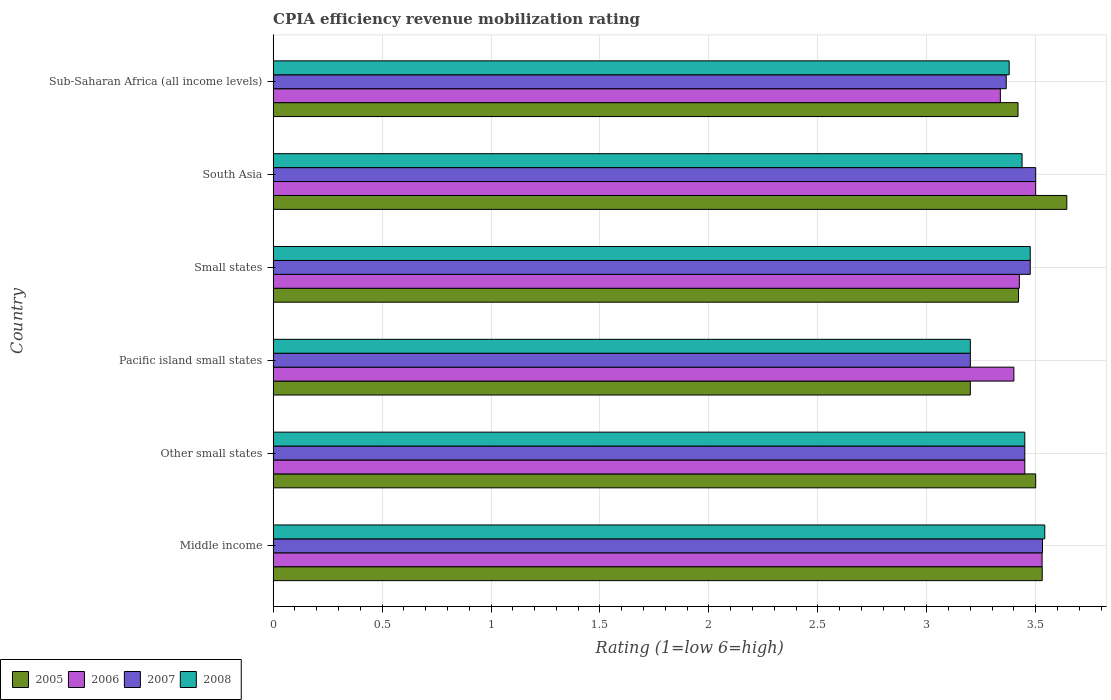How many groups of bars are there?
Your answer should be compact. 6. Are the number of bars per tick equal to the number of legend labels?
Offer a terse response. Yes. Are the number of bars on each tick of the Y-axis equal?
Make the answer very short. Yes. How many bars are there on the 1st tick from the bottom?
Your answer should be very brief. 4. What is the label of the 4th group of bars from the top?
Provide a short and direct response. Pacific island small states. In how many cases, is the number of bars for a given country not equal to the number of legend labels?
Give a very brief answer. 0. What is the CPIA rating in 2007 in South Asia?
Ensure brevity in your answer.  3.5. Across all countries, what is the maximum CPIA rating in 2005?
Keep it short and to the point. 3.64. Across all countries, what is the minimum CPIA rating in 2006?
Ensure brevity in your answer.  3.34. In which country was the CPIA rating in 2005 minimum?
Your response must be concise. Pacific island small states. What is the total CPIA rating in 2006 in the graph?
Your answer should be very brief. 20.64. What is the difference between the CPIA rating in 2007 in Pacific island small states and that in South Asia?
Give a very brief answer. -0.3. What is the difference between the CPIA rating in 2005 in Sub-Saharan Africa (all income levels) and the CPIA rating in 2006 in Middle income?
Offer a very short reply. -0.11. What is the average CPIA rating in 2008 per country?
Ensure brevity in your answer.  3.41. What is the difference between the CPIA rating in 2005 and CPIA rating in 2006 in Sub-Saharan Africa (all income levels)?
Keep it short and to the point. 0.08. In how many countries, is the CPIA rating in 2005 greater than 3.2 ?
Provide a short and direct response. 5. What is the ratio of the CPIA rating in 2006 in Other small states to that in Pacific island small states?
Make the answer very short. 1.01. Is the CPIA rating in 2005 in Other small states less than that in South Asia?
Provide a short and direct response. Yes. Is the difference between the CPIA rating in 2005 in Other small states and Sub-Saharan Africa (all income levels) greater than the difference between the CPIA rating in 2006 in Other small states and Sub-Saharan Africa (all income levels)?
Your answer should be compact. No. What is the difference between the highest and the second highest CPIA rating in 2008?
Ensure brevity in your answer.  0.07. What is the difference between the highest and the lowest CPIA rating in 2005?
Make the answer very short. 0.44. In how many countries, is the CPIA rating in 2005 greater than the average CPIA rating in 2005 taken over all countries?
Provide a succinct answer. 3. Is the sum of the CPIA rating in 2005 in Small states and Sub-Saharan Africa (all income levels) greater than the maximum CPIA rating in 2008 across all countries?
Keep it short and to the point. Yes. What does the 2nd bar from the top in Sub-Saharan Africa (all income levels) represents?
Offer a terse response. 2007. Is it the case that in every country, the sum of the CPIA rating in 2006 and CPIA rating in 2008 is greater than the CPIA rating in 2005?
Ensure brevity in your answer.  Yes. What is the difference between two consecutive major ticks on the X-axis?
Provide a succinct answer. 0.5. Does the graph contain any zero values?
Offer a very short reply. No. How many legend labels are there?
Ensure brevity in your answer.  4. What is the title of the graph?
Offer a terse response. CPIA efficiency revenue mobilization rating. What is the Rating (1=low 6=high) in 2005 in Middle income?
Provide a short and direct response. 3.53. What is the Rating (1=low 6=high) in 2006 in Middle income?
Provide a succinct answer. 3.53. What is the Rating (1=low 6=high) in 2007 in Middle income?
Offer a terse response. 3.53. What is the Rating (1=low 6=high) of 2008 in Middle income?
Your answer should be very brief. 3.54. What is the Rating (1=low 6=high) of 2006 in Other small states?
Your answer should be compact. 3.45. What is the Rating (1=low 6=high) in 2007 in Other small states?
Offer a very short reply. 3.45. What is the Rating (1=low 6=high) in 2008 in Other small states?
Your answer should be very brief. 3.45. What is the Rating (1=low 6=high) of 2005 in Small states?
Your response must be concise. 3.42. What is the Rating (1=low 6=high) in 2006 in Small states?
Make the answer very short. 3.42. What is the Rating (1=low 6=high) of 2007 in Small states?
Provide a succinct answer. 3.48. What is the Rating (1=low 6=high) of 2008 in Small states?
Give a very brief answer. 3.48. What is the Rating (1=low 6=high) of 2005 in South Asia?
Your answer should be compact. 3.64. What is the Rating (1=low 6=high) of 2006 in South Asia?
Provide a short and direct response. 3.5. What is the Rating (1=low 6=high) of 2008 in South Asia?
Your answer should be compact. 3.44. What is the Rating (1=low 6=high) in 2005 in Sub-Saharan Africa (all income levels)?
Keep it short and to the point. 3.42. What is the Rating (1=low 6=high) of 2006 in Sub-Saharan Africa (all income levels)?
Provide a succinct answer. 3.34. What is the Rating (1=low 6=high) in 2007 in Sub-Saharan Africa (all income levels)?
Make the answer very short. 3.36. What is the Rating (1=low 6=high) in 2008 in Sub-Saharan Africa (all income levels)?
Make the answer very short. 3.38. Across all countries, what is the maximum Rating (1=low 6=high) of 2005?
Ensure brevity in your answer.  3.64. Across all countries, what is the maximum Rating (1=low 6=high) of 2006?
Offer a terse response. 3.53. Across all countries, what is the maximum Rating (1=low 6=high) in 2007?
Make the answer very short. 3.53. Across all countries, what is the maximum Rating (1=low 6=high) in 2008?
Give a very brief answer. 3.54. Across all countries, what is the minimum Rating (1=low 6=high) in 2006?
Your response must be concise. 3.34. Across all countries, what is the minimum Rating (1=low 6=high) in 2007?
Offer a very short reply. 3.2. Across all countries, what is the minimum Rating (1=low 6=high) of 2008?
Offer a very short reply. 3.2. What is the total Rating (1=low 6=high) of 2005 in the graph?
Provide a succinct answer. 20.71. What is the total Rating (1=low 6=high) in 2006 in the graph?
Give a very brief answer. 20.64. What is the total Rating (1=low 6=high) of 2007 in the graph?
Offer a terse response. 20.52. What is the total Rating (1=low 6=high) of 2008 in the graph?
Your answer should be compact. 20.48. What is the difference between the Rating (1=low 6=high) of 2005 in Middle income and that in Other small states?
Make the answer very short. 0.03. What is the difference between the Rating (1=low 6=high) in 2006 in Middle income and that in Other small states?
Give a very brief answer. 0.08. What is the difference between the Rating (1=low 6=high) in 2007 in Middle income and that in Other small states?
Your answer should be very brief. 0.08. What is the difference between the Rating (1=low 6=high) in 2008 in Middle income and that in Other small states?
Your response must be concise. 0.09. What is the difference between the Rating (1=low 6=high) in 2005 in Middle income and that in Pacific island small states?
Offer a terse response. 0.33. What is the difference between the Rating (1=low 6=high) of 2006 in Middle income and that in Pacific island small states?
Ensure brevity in your answer.  0.13. What is the difference between the Rating (1=low 6=high) of 2007 in Middle income and that in Pacific island small states?
Your answer should be compact. 0.33. What is the difference between the Rating (1=low 6=high) of 2008 in Middle income and that in Pacific island small states?
Your answer should be compact. 0.34. What is the difference between the Rating (1=low 6=high) of 2005 in Middle income and that in Small states?
Provide a short and direct response. 0.11. What is the difference between the Rating (1=low 6=high) in 2006 in Middle income and that in Small states?
Your answer should be compact. 0.1. What is the difference between the Rating (1=low 6=high) in 2007 in Middle income and that in Small states?
Give a very brief answer. 0.06. What is the difference between the Rating (1=low 6=high) in 2008 in Middle income and that in Small states?
Offer a terse response. 0.07. What is the difference between the Rating (1=low 6=high) of 2005 in Middle income and that in South Asia?
Offer a very short reply. -0.11. What is the difference between the Rating (1=low 6=high) in 2006 in Middle income and that in South Asia?
Ensure brevity in your answer.  0.03. What is the difference between the Rating (1=low 6=high) in 2007 in Middle income and that in South Asia?
Your response must be concise. 0.03. What is the difference between the Rating (1=low 6=high) in 2008 in Middle income and that in South Asia?
Your answer should be compact. 0.1. What is the difference between the Rating (1=low 6=high) in 2006 in Middle income and that in Sub-Saharan Africa (all income levels)?
Offer a terse response. 0.19. What is the difference between the Rating (1=low 6=high) in 2007 in Middle income and that in Sub-Saharan Africa (all income levels)?
Offer a very short reply. 0.17. What is the difference between the Rating (1=low 6=high) in 2008 in Middle income and that in Sub-Saharan Africa (all income levels)?
Give a very brief answer. 0.16. What is the difference between the Rating (1=low 6=high) in 2005 in Other small states and that in Pacific island small states?
Offer a terse response. 0.3. What is the difference between the Rating (1=low 6=high) of 2005 in Other small states and that in Small states?
Your answer should be compact. 0.08. What is the difference between the Rating (1=low 6=high) in 2006 in Other small states and that in Small states?
Ensure brevity in your answer.  0.03. What is the difference between the Rating (1=low 6=high) in 2007 in Other small states and that in Small states?
Give a very brief answer. -0.03. What is the difference between the Rating (1=low 6=high) in 2008 in Other small states and that in Small states?
Your answer should be compact. -0.03. What is the difference between the Rating (1=low 6=high) in 2005 in Other small states and that in South Asia?
Your answer should be very brief. -0.14. What is the difference between the Rating (1=low 6=high) in 2008 in Other small states and that in South Asia?
Offer a very short reply. 0.01. What is the difference between the Rating (1=low 6=high) of 2005 in Other small states and that in Sub-Saharan Africa (all income levels)?
Ensure brevity in your answer.  0.08. What is the difference between the Rating (1=low 6=high) in 2006 in Other small states and that in Sub-Saharan Africa (all income levels)?
Provide a short and direct response. 0.11. What is the difference between the Rating (1=low 6=high) in 2007 in Other small states and that in Sub-Saharan Africa (all income levels)?
Keep it short and to the point. 0.09. What is the difference between the Rating (1=low 6=high) in 2008 in Other small states and that in Sub-Saharan Africa (all income levels)?
Offer a terse response. 0.07. What is the difference between the Rating (1=low 6=high) in 2005 in Pacific island small states and that in Small states?
Make the answer very short. -0.22. What is the difference between the Rating (1=low 6=high) of 2006 in Pacific island small states and that in Small states?
Your answer should be very brief. -0.03. What is the difference between the Rating (1=low 6=high) of 2007 in Pacific island small states and that in Small states?
Your answer should be very brief. -0.28. What is the difference between the Rating (1=low 6=high) in 2008 in Pacific island small states and that in Small states?
Your response must be concise. -0.28. What is the difference between the Rating (1=low 6=high) in 2005 in Pacific island small states and that in South Asia?
Give a very brief answer. -0.44. What is the difference between the Rating (1=low 6=high) in 2007 in Pacific island small states and that in South Asia?
Your answer should be very brief. -0.3. What is the difference between the Rating (1=low 6=high) of 2008 in Pacific island small states and that in South Asia?
Ensure brevity in your answer.  -0.24. What is the difference between the Rating (1=low 6=high) of 2005 in Pacific island small states and that in Sub-Saharan Africa (all income levels)?
Offer a very short reply. -0.22. What is the difference between the Rating (1=low 6=high) of 2006 in Pacific island small states and that in Sub-Saharan Africa (all income levels)?
Offer a terse response. 0.06. What is the difference between the Rating (1=low 6=high) in 2007 in Pacific island small states and that in Sub-Saharan Africa (all income levels)?
Offer a very short reply. -0.16. What is the difference between the Rating (1=low 6=high) in 2008 in Pacific island small states and that in Sub-Saharan Africa (all income levels)?
Keep it short and to the point. -0.18. What is the difference between the Rating (1=low 6=high) of 2005 in Small states and that in South Asia?
Provide a short and direct response. -0.22. What is the difference between the Rating (1=low 6=high) of 2006 in Small states and that in South Asia?
Your answer should be very brief. -0.07. What is the difference between the Rating (1=low 6=high) of 2007 in Small states and that in South Asia?
Keep it short and to the point. -0.03. What is the difference between the Rating (1=low 6=high) of 2008 in Small states and that in South Asia?
Your answer should be compact. 0.04. What is the difference between the Rating (1=low 6=high) of 2005 in Small states and that in Sub-Saharan Africa (all income levels)?
Keep it short and to the point. 0. What is the difference between the Rating (1=low 6=high) of 2006 in Small states and that in Sub-Saharan Africa (all income levels)?
Your answer should be very brief. 0.09. What is the difference between the Rating (1=low 6=high) in 2007 in Small states and that in Sub-Saharan Africa (all income levels)?
Your answer should be very brief. 0.11. What is the difference between the Rating (1=low 6=high) in 2008 in Small states and that in Sub-Saharan Africa (all income levels)?
Offer a terse response. 0.1. What is the difference between the Rating (1=low 6=high) in 2005 in South Asia and that in Sub-Saharan Africa (all income levels)?
Your answer should be very brief. 0.22. What is the difference between the Rating (1=low 6=high) in 2006 in South Asia and that in Sub-Saharan Africa (all income levels)?
Offer a terse response. 0.16. What is the difference between the Rating (1=low 6=high) of 2007 in South Asia and that in Sub-Saharan Africa (all income levels)?
Make the answer very short. 0.14. What is the difference between the Rating (1=low 6=high) of 2008 in South Asia and that in Sub-Saharan Africa (all income levels)?
Offer a very short reply. 0.06. What is the difference between the Rating (1=low 6=high) in 2005 in Middle income and the Rating (1=low 6=high) in 2008 in Other small states?
Provide a succinct answer. 0.08. What is the difference between the Rating (1=low 6=high) of 2006 in Middle income and the Rating (1=low 6=high) of 2007 in Other small states?
Provide a succinct answer. 0.08. What is the difference between the Rating (1=low 6=high) in 2006 in Middle income and the Rating (1=low 6=high) in 2008 in Other small states?
Your response must be concise. 0.08. What is the difference between the Rating (1=low 6=high) in 2007 in Middle income and the Rating (1=low 6=high) in 2008 in Other small states?
Keep it short and to the point. 0.08. What is the difference between the Rating (1=low 6=high) in 2005 in Middle income and the Rating (1=low 6=high) in 2006 in Pacific island small states?
Offer a terse response. 0.13. What is the difference between the Rating (1=low 6=high) in 2005 in Middle income and the Rating (1=low 6=high) in 2007 in Pacific island small states?
Keep it short and to the point. 0.33. What is the difference between the Rating (1=low 6=high) of 2005 in Middle income and the Rating (1=low 6=high) of 2008 in Pacific island small states?
Your response must be concise. 0.33. What is the difference between the Rating (1=low 6=high) of 2006 in Middle income and the Rating (1=low 6=high) of 2007 in Pacific island small states?
Offer a very short reply. 0.33. What is the difference between the Rating (1=low 6=high) in 2006 in Middle income and the Rating (1=low 6=high) in 2008 in Pacific island small states?
Offer a very short reply. 0.33. What is the difference between the Rating (1=low 6=high) in 2007 in Middle income and the Rating (1=low 6=high) in 2008 in Pacific island small states?
Your response must be concise. 0.33. What is the difference between the Rating (1=low 6=high) in 2005 in Middle income and the Rating (1=low 6=high) in 2006 in Small states?
Your answer should be compact. 0.1. What is the difference between the Rating (1=low 6=high) of 2005 in Middle income and the Rating (1=low 6=high) of 2007 in Small states?
Make the answer very short. 0.06. What is the difference between the Rating (1=low 6=high) in 2005 in Middle income and the Rating (1=low 6=high) in 2008 in Small states?
Offer a very short reply. 0.06. What is the difference between the Rating (1=low 6=high) of 2006 in Middle income and the Rating (1=low 6=high) of 2007 in Small states?
Your answer should be very brief. 0.05. What is the difference between the Rating (1=low 6=high) of 2006 in Middle income and the Rating (1=low 6=high) of 2008 in Small states?
Offer a very short reply. 0.05. What is the difference between the Rating (1=low 6=high) in 2007 in Middle income and the Rating (1=low 6=high) in 2008 in Small states?
Your response must be concise. 0.06. What is the difference between the Rating (1=low 6=high) of 2005 in Middle income and the Rating (1=low 6=high) of 2008 in South Asia?
Make the answer very short. 0.09. What is the difference between the Rating (1=low 6=high) of 2006 in Middle income and the Rating (1=low 6=high) of 2007 in South Asia?
Offer a terse response. 0.03. What is the difference between the Rating (1=low 6=high) of 2006 in Middle income and the Rating (1=low 6=high) of 2008 in South Asia?
Ensure brevity in your answer.  0.09. What is the difference between the Rating (1=low 6=high) in 2007 in Middle income and the Rating (1=low 6=high) in 2008 in South Asia?
Provide a short and direct response. 0.09. What is the difference between the Rating (1=low 6=high) in 2005 in Middle income and the Rating (1=low 6=high) in 2006 in Sub-Saharan Africa (all income levels)?
Provide a succinct answer. 0.19. What is the difference between the Rating (1=low 6=high) of 2005 in Middle income and the Rating (1=low 6=high) of 2007 in Sub-Saharan Africa (all income levels)?
Your answer should be very brief. 0.17. What is the difference between the Rating (1=low 6=high) of 2005 in Middle income and the Rating (1=low 6=high) of 2008 in Sub-Saharan Africa (all income levels)?
Provide a succinct answer. 0.15. What is the difference between the Rating (1=low 6=high) of 2006 in Middle income and the Rating (1=low 6=high) of 2007 in Sub-Saharan Africa (all income levels)?
Keep it short and to the point. 0.16. What is the difference between the Rating (1=low 6=high) of 2006 in Middle income and the Rating (1=low 6=high) of 2008 in Sub-Saharan Africa (all income levels)?
Offer a terse response. 0.15. What is the difference between the Rating (1=low 6=high) of 2007 in Middle income and the Rating (1=low 6=high) of 2008 in Sub-Saharan Africa (all income levels)?
Provide a short and direct response. 0.15. What is the difference between the Rating (1=low 6=high) of 2005 in Other small states and the Rating (1=low 6=high) of 2007 in Pacific island small states?
Make the answer very short. 0.3. What is the difference between the Rating (1=low 6=high) of 2007 in Other small states and the Rating (1=low 6=high) of 2008 in Pacific island small states?
Keep it short and to the point. 0.25. What is the difference between the Rating (1=low 6=high) in 2005 in Other small states and the Rating (1=low 6=high) in 2006 in Small states?
Ensure brevity in your answer.  0.07. What is the difference between the Rating (1=low 6=high) in 2005 in Other small states and the Rating (1=low 6=high) in 2007 in Small states?
Your answer should be very brief. 0.03. What is the difference between the Rating (1=low 6=high) of 2005 in Other small states and the Rating (1=low 6=high) of 2008 in Small states?
Provide a succinct answer. 0.03. What is the difference between the Rating (1=low 6=high) of 2006 in Other small states and the Rating (1=low 6=high) of 2007 in Small states?
Offer a terse response. -0.03. What is the difference between the Rating (1=low 6=high) of 2006 in Other small states and the Rating (1=low 6=high) of 2008 in Small states?
Keep it short and to the point. -0.03. What is the difference between the Rating (1=low 6=high) in 2007 in Other small states and the Rating (1=low 6=high) in 2008 in Small states?
Offer a terse response. -0.03. What is the difference between the Rating (1=low 6=high) in 2005 in Other small states and the Rating (1=low 6=high) in 2006 in South Asia?
Offer a terse response. 0. What is the difference between the Rating (1=low 6=high) in 2005 in Other small states and the Rating (1=low 6=high) in 2007 in South Asia?
Ensure brevity in your answer.  0. What is the difference between the Rating (1=low 6=high) of 2005 in Other small states and the Rating (1=low 6=high) of 2008 in South Asia?
Your answer should be very brief. 0.06. What is the difference between the Rating (1=low 6=high) of 2006 in Other small states and the Rating (1=low 6=high) of 2007 in South Asia?
Ensure brevity in your answer.  -0.05. What is the difference between the Rating (1=low 6=high) in 2006 in Other small states and the Rating (1=low 6=high) in 2008 in South Asia?
Provide a succinct answer. 0.01. What is the difference between the Rating (1=low 6=high) of 2007 in Other small states and the Rating (1=low 6=high) of 2008 in South Asia?
Make the answer very short. 0.01. What is the difference between the Rating (1=low 6=high) of 2005 in Other small states and the Rating (1=low 6=high) of 2006 in Sub-Saharan Africa (all income levels)?
Keep it short and to the point. 0.16. What is the difference between the Rating (1=low 6=high) in 2005 in Other small states and the Rating (1=low 6=high) in 2007 in Sub-Saharan Africa (all income levels)?
Your response must be concise. 0.14. What is the difference between the Rating (1=low 6=high) in 2005 in Other small states and the Rating (1=low 6=high) in 2008 in Sub-Saharan Africa (all income levels)?
Keep it short and to the point. 0.12. What is the difference between the Rating (1=low 6=high) in 2006 in Other small states and the Rating (1=low 6=high) in 2007 in Sub-Saharan Africa (all income levels)?
Make the answer very short. 0.09. What is the difference between the Rating (1=low 6=high) in 2006 in Other small states and the Rating (1=low 6=high) in 2008 in Sub-Saharan Africa (all income levels)?
Make the answer very short. 0.07. What is the difference between the Rating (1=low 6=high) in 2007 in Other small states and the Rating (1=low 6=high) in 2008 in Sub-Saharan Africa (all income levels)?
Offer a terse response. 0.07. What is the difference between the Rating (1=low 6=high) in 2005 in Pacific island small states and the Rating (1=low 6=high) in 2006 in Small states?
Your answer should be very brief. -0.23. What is the difference between the Rating (1=low 6=high) of 2005 in Pacific island small states and the Rating (1=low 6=high) of 2007 in Small states?
Your response must be concise. -0.28. What is the difference between the Rating (1=low 6=high) in 2005 in Pacific island small states and the Rating (1=low 6=high) in 2008 in Small states?
Give a very brief answer. -0.28. What is the difference between the Rating (1=low 6=high) in 2006 in Pacific island small states and the Rating (1=low 6=high) in 2007 in Small states?
Make the answer very short. -0.07. What is the difference between the Rating (1=low 6=high) in 2006 in Pacific island small states and the Rating (1=low 6=high) in 2008 in Small states?
Your answer should be compact. -0.07. What is the difference between the Rating (1=low 6=high) in 2007 in Pacific island small states and the Rating (1=low 6=high) in 2008 in Small states?
Your response must be concise. -0.28. What is the difference between the Rating (1=low 6=high) of 2005 in Pacific island small states and the Rating (1=low 6=high) of 2007 in South Asia?
Your answer should be compact. -0.3. What is the difference between the Rating (1=low 6=high) of 2005 in Pacific island small states and the Rating (1=low 6=high) of 2008 in South Asia?
Provide a short and direct response. -0.24. What is the difference between the Rating (1=low 6=high) of 2006 in Pacific island small states and the Rating (1=low 6=high) of 2008 in South Asia?
Your response must be concise. -0.04. What is the difference between the Rating (1=low 6=high) of 2007 in Pacific island small states and the Rating (1=low 6=high) of 2008 in South Asia?
Ensure brevity in your answer.  -0.24. What is the difference between the Rating (1=low 6=high) of 2005 in Pacific island small states and the Rating (1=low 6=high) of 2006 in Sub-Saharan Africa (all income levels)?
Ensure brevity in your answer.  -0.14. What is the difference between the Rating (1=low 6=high) in 2005 in Pacific island small states and the Rating (1=low 6=high) in 2007 in Sub-Saharan Africa (all income levels)?
Keep it short and to the point. -0.16. What is the difference between the Rating (1=low 6=high) in 2005 in Pacific island small states and the Rating (1=low 6=high) in 2008 in Sub-Saharan Africa (all income levels)?
Offer a very short reply. -0.18. What is the difference between the Rating (1=low 6=high) in 2006 in Pacific island small states and the Rating (1=low 6=high) in 2007 in Sub-Saharan Africa (all income levels)?
Your answer should be very brief. 0.04. What is the difference between the Rating (1=low 6=high) in 2006 in Pacific island small states and the Rating (1=low 6=high) in 2008 in Sub-Saharan Africa (all income levels)?
Offer a terse response. 0.02. What is the difference between the Rating (1=low 6=high) of 2007 in Pacific island small states and the Rating (1=low 6=high) of 2008 in Sub-Saharan Africa (all income levels)?
Give a very brief answer. -0.18. What is the difference between the Rating (1=low 6=high) in 2005 in Small states and the Rating (1=low 6=high) in 2006 in South Asia?
Keep it short and to the point. -0.08. What is the difference between the Rating (1=low 6=high) in 2005 in Small states and the Rating (1=low 6=high) in 2007 in South Asia?
Your response must be concise. -0.08. What is the difference between the Rating (1=low 6=high) in 2005 in Small states and the Rating (1=low 6=high) in 2008 in South Asia?
Ensure brevity in your answer.  -0.02. What is the difference between the Rating (1=low 6=high) in 2006 in Small states and the Rating (1=low 6=high) in 2007 in South Asia?
Your response must be concise. -0.07. What is the difference between the Rating (1=low 6=high) in 2006 in Small states and the Rating (1=low 6=high) in 2008 in South Asia?
Your response must be concise. -0.01. What is the difference between the Rating (1=low 6=high) in 2007 in Small states and the Rating (1=low 6=high) in 2008 in South Asia?
Offer a very short reply. 0.04. What is the difference between the Rating (1=low 6=high) in 2005 in Small states and the Rating (1=low 6=high) in 2006 in Sub-Saharan Africa (all income levels)?
Make the answer very short. 0.08. What is the difference between the Rating (1=low 6=high) of 2005 in Small states and the Rating (1=low 6=high) of 2007 in Sub-Saharan Africa (all income levels)?
Keep it short and to the point. 0.06. What is the difference between the Rating (1=low 6=high) of 2005 in Small states and the Rating (1=low 6=high) of 2008 in Sub-Saharan Africa (all income levels)?
Keep it short and to the point. 0.04. What is the difference between the Rating (1=low 6=high) in 2006 in Small states and the Rating (1=low 6=high) in 2007 in Sub-Saharan Africa (all income levels)?
Offer a terse response. 0.06. What is the difference between the Rating (1=low 6=high) of 2006 in Small states and the Rating (1=low 6=high) of 2008 in Sub-Saharan Africa (all income levels)?
Make the answer very short. 0.05. What is the difference between the Rating (1=low 6=high) of 2007 in Small states and the Rating (1=low 6=high) of 2008 in Sub-Saharan Africa (all income levels)?
Ensure brevity in your answer.  0.1. What is the difference between the Rating (1=low 6=high) of 2005 in South Asia and the Rating (1=low 6=high) of 2006 in Sub-Saharan Africa (all income levels)?
Offer a very short reply. 0.3. What is the difference between the Rating (1=low 6=high) in 2005 in South Asia and the Rating (1=low 6=high) in 2007 in Sub-Saharan Africa (all income levels)?
Keep it short and to the point. 0.28. What is the difference between the Rating (1=low 6=high) of 2005 in South Asia and the Rating (1=low 6=high) of 2008 in Sub-Saharan Africa (all income levels)?
Give a very brief answer. 0.26. What is the difference between the Rating (1=low 6=high) of 2006 in South Asia and the Rating (1=low 6=high) of 2007 in Sub-Saharan Africa (all income levels)?
Provide a short and direct response. 0.14. What is the difference between the Rating (1=low 6=high) in 2006 in South Asia and the Rating (1=low 6=high) in 2008 in Sub-Saharan Africa (all income levels)?
Offer a very short reply. 0.12. What is the difference between the Rating (1=low 6=high) in 2007 in South Asia and the Rating (1=low 6=high) in 2008 in Sub-Saharan Africa (all income levels)?
Your response must be concise. 0.12. What is the average Rating (1=low 6=high) of 2005 per country?
Give a very brief answer. 3.45. What is the average Rating (1=low 6=high) in 2006 per country?
Ensure brevity in your answer.  3.44. What is the average Rating (1=low 6=high) in 2007 per country?
Make the answer very short. 3.42. What is the average Rating (1=low 6=high) in 2008 per country?
Keep it short and to the point. 3.41. What is the difference between the Rating (1=low 6=high) of 2005 and Rating (1=low 6=high) of 2006 in Middle income?
Your answer should be compact. 0. What is the difference between the Rating (1=low 6=high) in 2005 and Rating (1=low 6=high) in 2007 in Middle income?
Your response must be concise. -0. What is the difference between the Rating (1=low 6=high) of 2005 and Rating (1=low 6=high) of 2008 in Middle income?
Ensure brevity in your answer.  -0.01. What is the difference between the Rating (1=low 6=high) in 2006 and Rating (1=low 6=high) in 2007 in Middle income?
Offer a very short reply. -0. What is the difference between the Rating (1=low 6=high) of 2006 and Rating (1=low 6=high) of 2008 in Middle income?
Ensure brevity in your answer.  -0.01. What is the difference between the Rating (1=low 6=high) of 2007 and Rating (1=low 6=high) of 2008 in Middle income?
Offer a very short reply. -0.01. What is the difference between the Rating (1=low 6=high) of 2005 and Rating (1=low 6=high) of 2007 in Other small states?
Provide a short and direct response. 0.05. What is the difference between the Rating (1=low 6=high) of 2005 and Rating (1=low 6=high) of 2008 in Other small states?
Keep it short and to the point. 0.05. What is the difference between the Rating (1=low 6=high) in 2006 and Rating (1=low 6=high) in 2008 in Other small states?
Give a very brief answer. 0. What is the difference between the Rating (1=low 6=high) of 2007 and Rating (1=low 6=high) of 2008 in Other small states?
Ensure brevity in your answer.  0. What is the difference between the Rating (1=low 6=high) of 2005 and Rating (1=low 6=high) of 2006 in Pacific island small states?
Offer a very short reply. -0.2. What is the difference between the Rating (1=low 6=high) of 2005 and Rating (1=low 6=high) of 2007 in Pacific island small states?
Offer a very short reply. 0. What is the difference between the Rating (1=low 6=high) of 2006 and Rating (1=low 6=high) of 2007 in Pacific island small states?
Provide a succinct answer. 0.2. What is the difference between the Rating (1=low 6=high) of 2006 and Rating (1=low 6=high) of 2008 in Pacific island small states?
Your response must be concise. 0.2. What is the difference between the Rating (1=low 6=high) of 2005 and Rating (1=low 6=high) of 2006 in Small states?
Your answer should be compact. -0. What is the difference between the Rating (1=low 6=high) of 2005 and Rating (1=low 6=high) of 2007 in Small states?
Your answer should be very brief. -0.05. What is the difference between the Rating (1=low 6=high) of 2005 and Rating (1=low 6=high) of 2008 in Small states?
Your answer should be compact. -0.05. What is the difference between the Rating (1=low 6=high) of 2006 and Rating (1=low 6=high) of 2008 in Small states?
Offer a very short reply. -0.05. What is the difference between the Rating (1=low 6=high) of 2007 and Rating (1=low 6=high) of 2008 in Small states?
Provide a short and direct response. 0. What is the difference between the Rating (1=low 6=high) of 2005 and Rating (1=low 6=high) of 2006 in South Asia?
Give a very brief answer. 0.14. What is the difference between the Rating (1=low 6=high) in 2005 and Rating (1=low 6=high) in 2007 in South Asia?
Ensure brevity in your answer.  0.14. What is the difference between the Rating (1=low 6=high) in 2005 and Rating (1=low 6=high) in 2008 in South Asia?
Make the answer very short. 0.21. What is the difference between the Rating (1=low 6=high) of 2006 and Rating (1=low 6=high) of 2007 in South Asia?
Keep it short and to the point. 0. What is the difference between the Rating (1=low 6=high) of 2006 and Rating (1=low 6=high) of 2008 in South Asia?
Your response must be concise. 0.06. What is the difference between the Rating (1=low 6=high) of 2007 and Rating (1=low 6=high) of 2008 in South Asia?
Offer a terse response. 0.06. What is the difference between the Rating (1=low 6=high) of 2005 and Rating (1=low 6=high) of 2006 in Sub-Saharan Africa (all income levels)?
Give a very brief answer. 0.08. What is the difference between the Rating (1=low 6=high) of 2005 and Rating (1=low 6=high) of 2007 in Sub-Saharan Africa (all income levels)?
Offer a very short reply. 0.05. What is the difference between the Rating (1=low 6=high) of 2005 and Rating (1=low 6=high) of 2008 in Sub-Saharan Africa (all income levels)?
Make the answer very short. 0.04. What is the difference between the Rating (1=low 6=high) in 2006 and Rating (1=low 6=high) in 2007 in Sub-Saharan Africa (all income levels)?
Your answer should be compact. -0.03. What is the difference between the Rating (1=low 6=high) in 2006 and Rating (1=low 6=high) in 2008 in Sub-Saharan Africa (all income levels)?
Provide a short and direct response. -0.04. What is the difference between the Rating (1=low 6=high) in 2007 and Rating (1=low 6=high) in 2008 in Sub-Saharan Africa (all income levels)?
Keep it short and to the point. -0.01. What is the ratio of the Rating (1=low 6=high) of 2005 in Middle income to that in Other small states?
Make the answer very short. 1.01. What is the ratio of the Rating (1=low 6=high) of 2007 in Middle income to that in Other small states?
Ensure brevity in your answer.  1.02. What is the ratio of the Rating (1=low 6=high) of 2008 in Middle income to that in Other small states?
Ensure brevity in your answer.  1.03. What is the ratio of the Rating (1=low 6=high) of 2005 in Middle income to that in Pacific island small states?
Offer a terse response. 1.1. What is the ratio of the Rating (1=low 6=high) in 2006 in Middle income to that in Pacific island small states?
Your answer should be very brief. 1.04. What is the ratio of the Rating (1=low 6=high) in 2007 in Middle income to that in Pacific island small states?
Provide a short and direct response. 1.1. What is the ratio of the Rating (1=low 6=high) in 2008 in Middle income to that in Pacific island small states?
Keep it short and to the point. 1.11. What is the ratio of the Rating (1=low 6=high) of 2005 in Middle income to that in Small states?
Your answer should be compact. 1.03. What is the ratio of the Rating (1=low 6=high) of 2006 in Middle income to that in Small states?
Make the answer very short. 1.03. What is the ratio of the Rating (1=low 6=high) of 2007 in Middle income to that in Small states?
Offer a terse response. 1.02. What is the ratio of the Rating (1=low 6=high) of 2008 in Middle income to that in Small states?
Your answer should be compact. 1.02. What is the ratio of the Rating (1=low 6=high) in 2006 in Middle income to that in South Asia?
Your response must be concise. 1.01. What is the ratio of the Rating (1=low 6=high) of 2007 in Middle income to that in South Asia?
Keep it short and to the point. 1.01. What is the ratio of the Rating (1=low 6=high) of 2008 in Middle income to that in South Asia?
Give a very brief answer. 1.03. What is the ratio of the Rating (1=low 6=high) in 2005 in Middle income to that in Sub-Saharan Africa (all income levels)?
Offer a terse response. 1.03. What is the ratio of the Rating (1=low 6=high) in 2006 in Middle income to that in Sub-Saharan Africa (all income levels)?
Provide a short and direct response. 1.06. What is the ratio of the Rating (1=low 6=high) of 2007 in Middle income to that in Sub-Saharan Africa (all income levels)?
Keep it short and to the point. 1.05. What is the ratio of the Rating (1=low 6=high) in 2008 in Middle income to that in Sub-Saharan Africa (all income levels)?
Your response must be concise. 1.05. What is the ratio of the Rating (1=low 6=high) in 2005 in Other small states to that in Pacific island small states?
Your answer should be compact. 1.09. What is the ratio of the Rating (1=low 6=high) in 2006 in Other small states to that in Pacific island small states?
Ensure brevity in your answer.  1.01. What is the ratio of the Rating (1=low 6=high) in 2007 in Other small states to that in Pacific island small states?
Provide a short and direct response. 1.08. What is the ratio of the Rating (1=low 6=high) in 2008 in Other small states to that in Pacific island small states?
Provide a short and direct response. 1.08. What is the ratio of the Rating (1=low 6=high) in 2005 in Other small states to that in Small states?
Your response must be concise. 1.02. What is the ratio of the Rating (1=low 6=high) in 2006 in Other small states to that in Small states?
Provide a succinct answer. 1.01. What is the ratio of the Rating (1=low 6=high) of 2008 in Other small states to that in Small states?
Offer a very short reply. 0.99. What is the ratio of the Rating (1=low 6=high) in 2005 in Other small states to that in South Asia?
Offer a very short reply. 0.96. What is the ratio of the Rating (1=low 6=high) of 2006 in Other small states to that in South Asia?
Provide a succinct answer. 0.99. What is the ratio of the Rating (1=low 6=high) in 2007 in Other small states to that in South Asia?
Give a very brief answer. 0.99. What is the ratio of the Rating (1=low 6=high) in 2005 in Other small states to that in Sub-Saharan Africa (all income levels)?
Offer a very short reply. 1.02. What is the ratio of the Rating (1=low 6=high) of 2006 in Other small states to that in Sub-Saharan Africa (all income levels)?
Give a very brief answer. 1.03. What is the ratio of the Rating (1=low 6=high) of 2007 in Other small states to that in Sub-Saharan Africa (all income levels)?
Keep it short and to the point. 1.03. What is the ratio of the Rating (1=low 6=high) in 2008 in Other small states to that in Sub-Saharan Africa (all income levels)?
Offer a terse response. 1.02. What is the ratio of the Rating (1=low 6=high) of 2005 in Pacific island small states to that in Small states?
Provide a succinct answer. 0.94. What is the ratio of the Rating (1=low 6=high) of 2007 in Pacific island small states to that in Small states?
Provide a succinct answer. 0.92. What is the ratio of the Rating (1=low 6=high) of 2008 in Pacific island small states to that in Small states?
Provide a short and direct response. 0.92. What is the ratio of the Rating (1=low 6=high) of 2005 in Pacific island small states to that in South Asia?
Give a very brief answer. 0.88. What is the ratio of the Rating (1=low 6=high) in 2006 in Pacific island small states to that in South Asia?
Give a very brief answer. 0.97. What is the ratio of the Rating (1=low 6=high) in 2007 in Pacific island small states to that in South Asia?
Ensure brevity in your answer.  0.91. What is the ratio of the Rating (1=low 6=high) of 2008 in Pacific island small states to that in South Asia?
Provide a succinct answer. 0.93. What is the ratio of the Rating (1=low 6=high) of 2005 in Pacific island small states to that in Sub-Saharan Africa (all income levels)?
Your answer should be very brief. 0.94. What is the ratio of the Rating (1=low 6=high) of 2006 in Pacific island small states to that in Sub-Saharan Africa (all income levels)?
Keep it short and to the point. 1.02. What is the ratio of the Rating (1=low 6=high) in 2007 in Pacific island small states to that in Sub-Saharan Africa (all income levels)?
Provide a succinct answer. 0.95. What is the ratio of the Rating (1=low 6=high) in 2008 in Pacific island small states to that in Sub-Saharan Africa (all income levels)?
Your answer should be compact. 0.95. What is the ratio of the Rating (1=low 6=high) in 2005 in Small states to that in South Asia?
Keep it short and to the point. 0.94. What is the ratio of the Rating (1=low 6=high) of 2006 in Small states to that in South Asia?
Provide a succinct answer. 0.98. What is the ratio of the Rating (1=low 6=high) in 2007 in Small states to that in South Asia?
Make the answer very short. 0.99. What is the ratio of the Rating (1=low 6=high) of 2008 in Small states to that in South Asia?
Your response must be concise. 1.01. What is the ratio of the Rating (1=low 6=high) in 2006 in Small states to that in Sub-Saharan Africa (all income levels)?
Provide a succinct answer. 1.03. What is the ratio of the Rating (1=low 6=high) of 2007 in Small states to that in Sub-Saharan Africa (all income levels)?
Offer a terse response. 1.03. What is the ratio of the Rating (1=low 6=high) of 2008 in Small states to that in Sub-Saharan Africa (all income levels)?
Your answer should be compact. 1.03. What is the ratio of the Rating (1=low 6=high) of 2005 in South Asia to that in Sub-Saharan Africa (all income levels)?
Your answer should be very brief. 1.07. What is the ratio of the Rating (1=low 6=high) of 2006 in South Asia to that in Sub-Saharan Africa (all income levels)?
Give a very brief answer. 1.05. What is the ratio of the Rating (1=low 6=high) of 2007 in South Asia to that in Sub-Saharan Africa (all income levels)?
Make the answer very short. 1.04. What is the ratio of the Rating (1=low 6=high) of 2008 in South Asia to that in Sub-Saharan Africa (all income levels)?
Provide a short and direct response. 1.02. What is the difference between the highest and the second highest Rating (1=low 6=high) of 2005?
Your answer should be compact. 0.11. What is the difference between the highest and the second highest Rating (1=low 6=high) of 2006?
Ensure brevity in your answer.  0.03. What is the difference between the highest and the second highest Rating (1=low 6=high) in 2007?
Make the answer very short. 0.03. What is the difference between the highest and the second highest Rating (1=low 6=high) of 2008?
Ensure brevity in your answer.  0.07. What is the difference between the highest and the lowest Rating (1=low 6=high) of 2005?
Your response must be concise. 0.44. What is the difference between the highest and the lowest Rating (1=low 6=high) of 2006?
Your answer should be very brief. 0.19. What is the difference between the highest and the lowest Rating (1=low 6=high) in 2007?
Make the answer very short. 0.33. What is the difference between the highest and the lowest Rating (1=low 6=high) of 2008?
Your answer should be very brief. 0.34. 